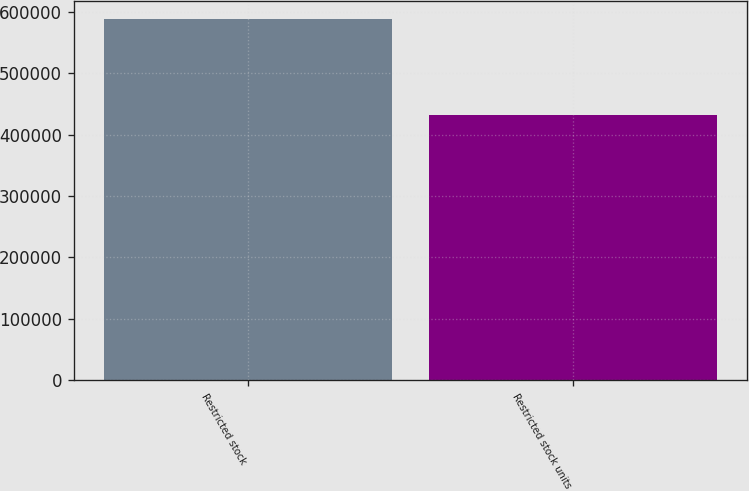Convert chart to OTSL. <chart><loc_0><loc_0><loc_500><loc_500><bar_chart><fcel>Restricted stock<fcel>Restricted stock units<nl><fcel>589150<fcel>432700<nl></chart> 